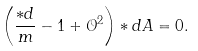Convert formula to latex. <formula><loc_0><loc_0><loc_500><loc_500>\left ( \frac { \ast d } { m } - 1 + \mathcal { O } ^ { 2 } \right ) \ast d A = 0 .</formula> 